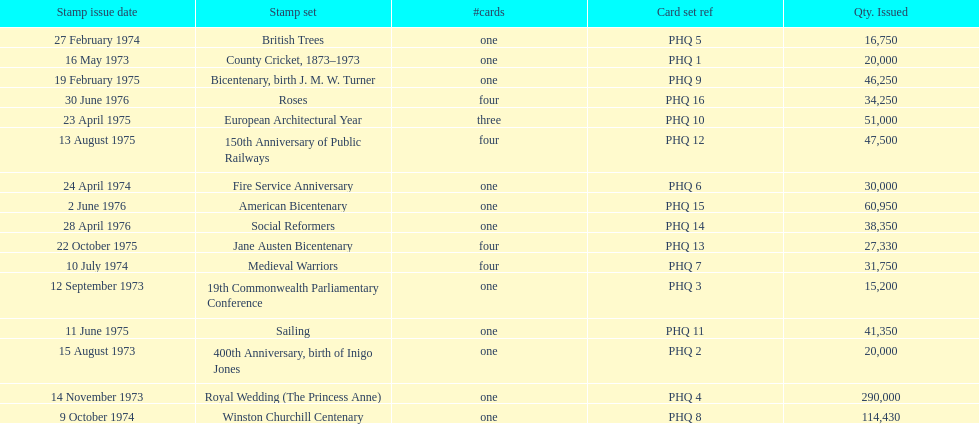How many stamp sets had at least 50,000 issued? 4. 